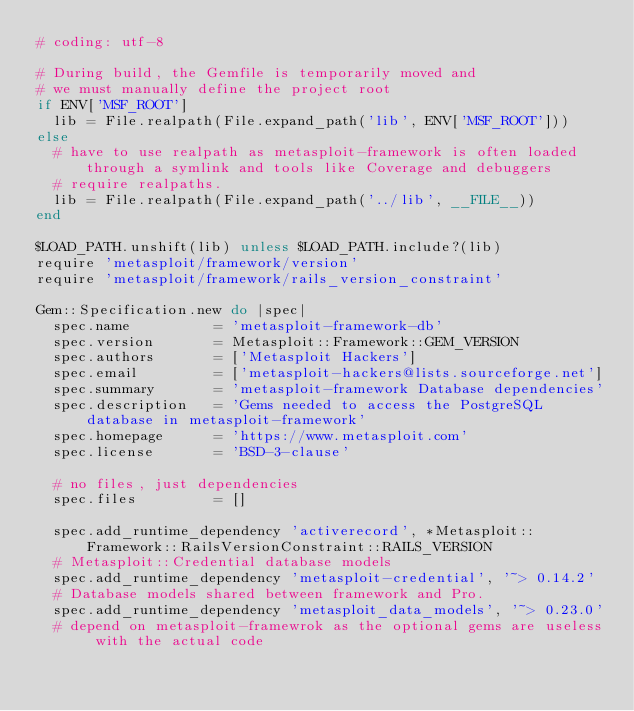Convert code to text. <code><loc_0><loc_0><loc_500><loc_500><_Ruby_># coding: utf-8

# During build, the Gemfile is temporarily moved and
# we must manually define the project root
if ENV['MSF_ROOT']
  lib = File.realpath(File.expand_path('lib', ENV['MSF_ROOT']))
else
  # have to use realpath as metasploit-framework is often loaded through a symlink and tools like Coverage and debuggers
  # require realpaths.
  lib = File.realpath(File.expand_path('../lib', __FILE__))
end

$LOAD_PATH.unshift(lib) unless $LOAD_PATH.include?(lib)
require 'metasploit/framework/version'
require 'metasploit/framework/rails_version_constraint'

Gem::Specification.new do |spec|
  spec.name          = 'metasploit-framework-db'
  spec.version       = Metasploit::Framework::GEM_VERSION
  spec.authors       = ['Metasploit Hackers']
  spec.email         = ['metasploit-hackers@lists.sourceforge.net']
  spec.summary       = 'metasploit-framework Database dependencies'
  spec.description   = 'Gems needed to access the PostgreSQL database in metasploit-framework'
  spec.homepage      = 'https://www.metasploit.com'
  spec.license       = 'BSD-3-clause'

  # no files, just dependencies
  spec.files         = []

  spec.add_runtime_dependency 'activerecord', *Metasploit::Framework::RailsVersionConstraint::RAILS_VERSION
  # Metasploit::Credential database models
  spec.add_runtime_dependency 'metasploit-credential', '~> 0.14.2'
  # Database models shared between framework and Pro.
  spec.add_runtime_dependency 'metasploit_data_models', '~> 0.23.0'
  # depend on metasploit-framewrok as the optional gems are useless with the actual code</code> 